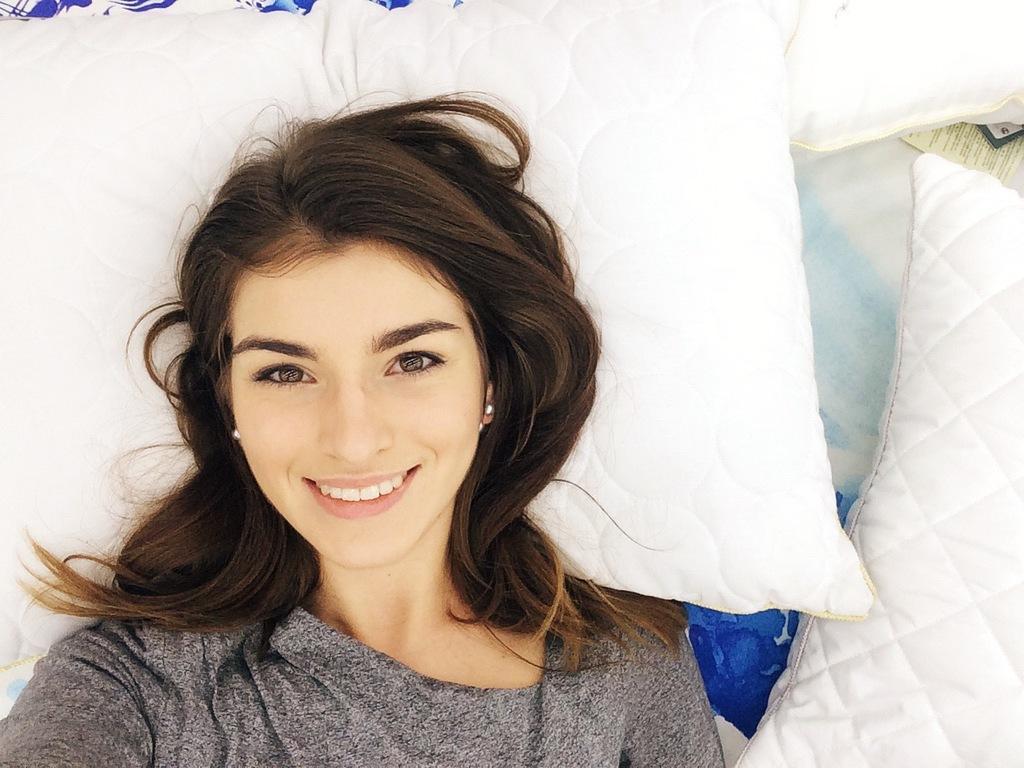In one or two sentences, can you explain what this image depicts? In the foreground I can see a woman is lying on the bed and cushions. This image is taken may be in a room. 